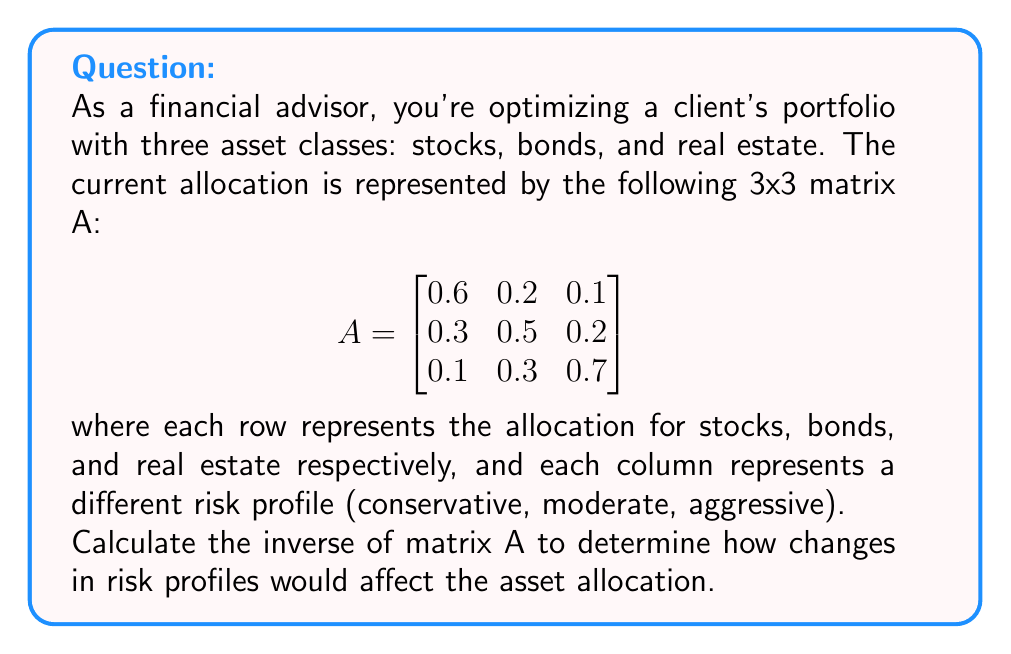Solve this math problem. To find the inverse of matrix A, we'll follow these steps:

1. Calculate the determinant of A
2. Find the matrix of cofactors
3. Transpose the matrix of cofactors to get the adjugate matrix
4. Divide the adjugate matrix by the determinant

Step 1: Calculate the determinant of A

$$\begin{aligned}
det(A) &= 0.6(0.5 \cdot 0.7 - 0.2 \cdot 0.3) - 0.2(0.3 \cdot 0.7 - 0.2 \cdot 0.1) + 0.1(0.3 \cdot 0.3 - 0.5 \cdot 0.1) \\
&= 0.6(0.35 - 0.06) - 0.2(0.21 - 0.02) + 0.1(0.09 - 0.05) \\
&= 0.6(0.29) - 0.2(0.19) + 0.1(0.04) \\
&= 0.174 - 0.038 + 0.004 \\
&= 0.14
\end{aligned}$$

Step 2: Find the matrix of cofactors

$$C = \begin{bmatrix}
(0.5 \cdot 0.7 - 0.2 \cdot 0.3) & -(0.3 \cdot 0.7 - 0.1 \cdot 0.3) & (0.3 \cdot 0.2 - 0.1 \cdot 0.5) \\
-(0.2 \cdot 0.7 - 0.1 \cdot 0.3) & (0.6 \cdot 0.7 - 0.1 \cdot 0.1) & -(0.6 \cdot 0.2 - 0.1 \cdot 0.2) \\
(0.2 \cdot 0.5 - 0.3 \cdot 0.2) & -(0.6 \cdot 0.5 - 0.3 \cdot 0.1) & (0.6 \cdot 0.5 - 0.2 \cdot 0.3)
\end{bmatrix}$$

$$C = \begin{bmatrix}
0.29 & -0.18 & 0.01 \\
-0.11 & 0.41 & -0.10 \\
0.04 & -0.27 & 0.24
\end{bmatrix}$$

Step 3: Transpose the matrix of cofactors to get the adjugate matrix

$$adj(A) = C^T = \begin{bmatrix}
0.29 & -0.11 & 0.04 \\
-0.18 & 0.41 & -0.27 \\
0.01 & -0.10 & 0.24
\end{bmatrix}$$

Step 4: Divide the adjugate matrix by the determinant

$$A^{-1} = \frac{1}{det(A)} \cdot adj(A) = \frac{1}{0.14} \cdot \begin{bmatrix}
0.29 & -0.11 & 0.04 \\
-0.18 & 0.41 & -0.27 \\
0.01 & -0.10 & 0.24
\end{bmatrix}$$

$$A^{-1} = \begin{bmatrix}
2.0714 & -0.7857 & 0.2857 \\
-1.2857 & 2.9286 & -1.9286 \\
0.0714 & -0.7143 & 1.7143
\end{bmatrix}$$
Answer: The inverse of matrix A is:

$$A^{-1} = \begin{bmatrix}
2.0714 & -0.7857 & 0.2857 \\
-1.2857 & 2.9286 & -1.9286 \\
0.0714 & -0.7143 & 1.7143
\end{bmatrix}$$ 